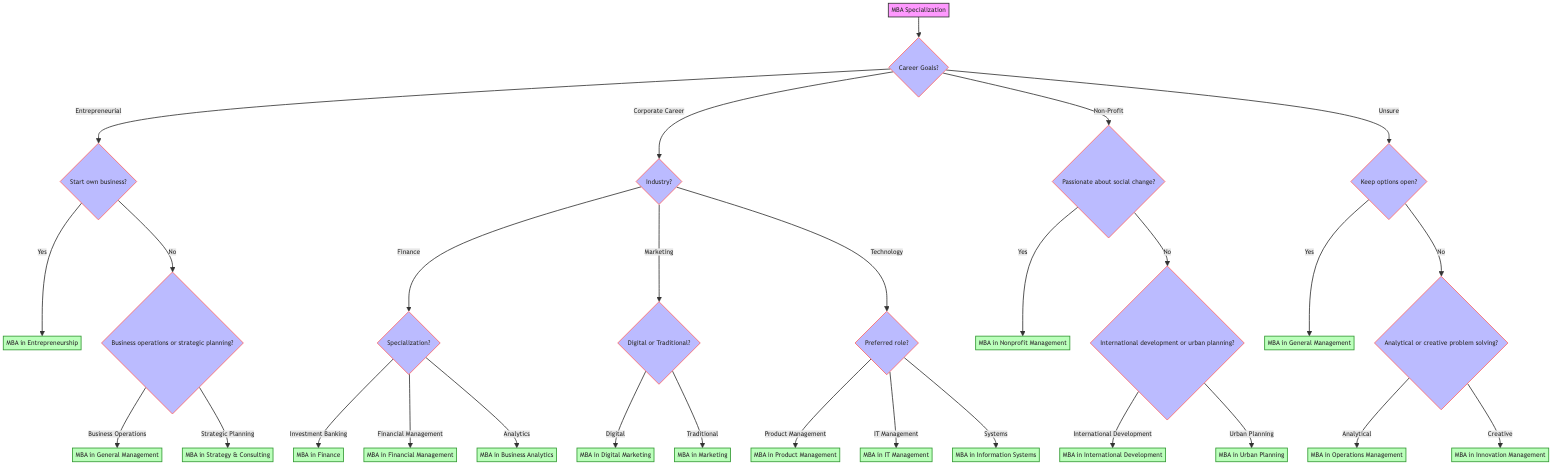What are the options under "Corporate Career"? Under the "Corporate Career" node, there are three options: "Finance," "Marketing," and "Technology." These options lead to further specialization questions.
Answer: Finance, Marketing, Technology What would the output be if the user is oriented toward "nonProfit" and they are passionate about social change? If the user is oriented toward "nonProfit" and passionate about social change, they will reach the endpoint "MBA in Nonprofit Management." This is a direct result from the node branching based on their passion.
Answer: MBA in Nonprofit Management How many total endpoints are there in the decision tree? Counting each unique specialization leads to a total of 9 endpoints, which are the final outcomes of various decision paths in the tree.
Answer: 9 If someone is interested in a "full-time" program, what will be the corresponding output? The output for someone preferring a "full-time" program would lead to the "Full-Time MBA Program" endpoint, showing their selected program format. There’s no branching involved here, so it’s a direct path.
Answer: Full-Time MBA Program What is the specialization for someone whose career goals include 'analytical' problem solving? If a person's career goal leans towards 'analytical' problem solving, they will reach the endpoint "MBA in Operations Management," according to the flow of decision-making structured in the diagram.
Answer: MBA in Operations Management What decision node follows after indicating "entrepreneurial" as a career goal? Once "entrepreneurial" is selected as a career goal, the next decision node is whether the individual wants to start their own business, leading to sub-options accordingly.
Answer: Start own business? What happens if someone answers "no" to the question about starting their own business under the "entrepreneurial" branch? If the answer is "no," they are directed to a new question regarding business operations or strategic planning, which then branches into either "MBA in General Management" or "MBA in Strategy & Consulting."
Answer: MBA in General Management or MBA in Strategy & Consulting Which location preferences are available in the diagram? The diagram lists four location preferences: North America, Europe, Asia, and Australia, with an additional flexible option for those who are open for various regions.
Answer: North America, Europe, Asia, Australia, flexible In the event of selecting "technology" industry, what options are available? After choosing "technology," the options available are: "Product Management," "IT Management," and "Systems," leading to specific MBA specializations.
Answer: Product Management, IT Management, Systems 